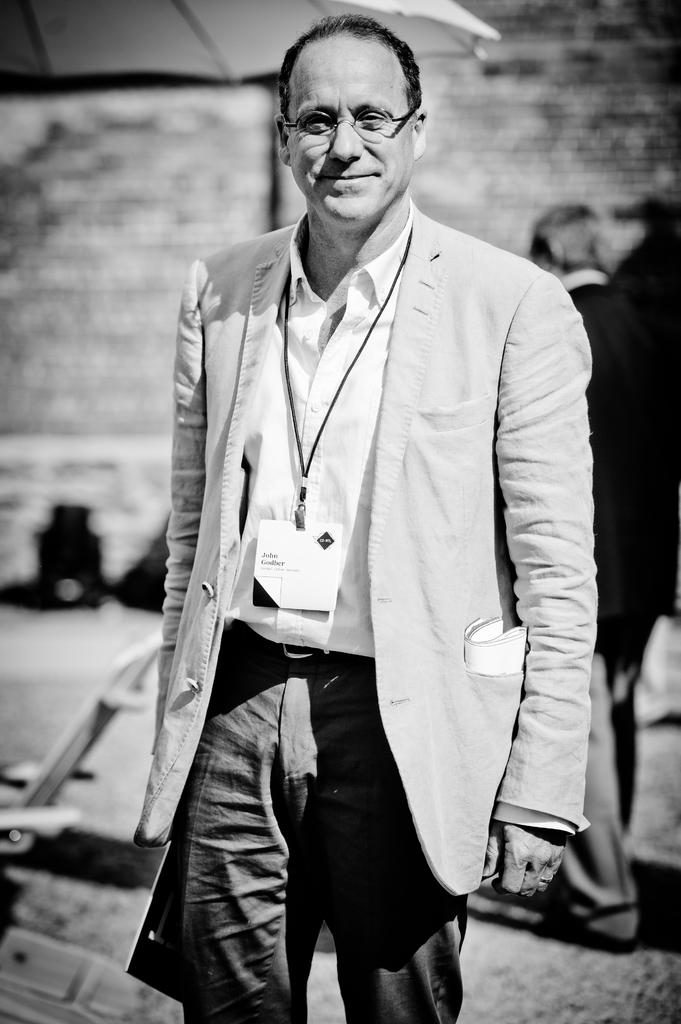What is the color scheme of the image? The image is black and white. What can be seen in the image? There are men standing in the image. Where are the men standing? The men are standing on the ground. What other object is present in the image? There is a chair in the image. What type of locket is hanging from the chair in the image? There is no locket present in the image; it only features men standing on the ground and a chair. 